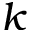Convert formula to latex. <formula><loc_0><loc_0><loc_500><loc_500>k</formula> 